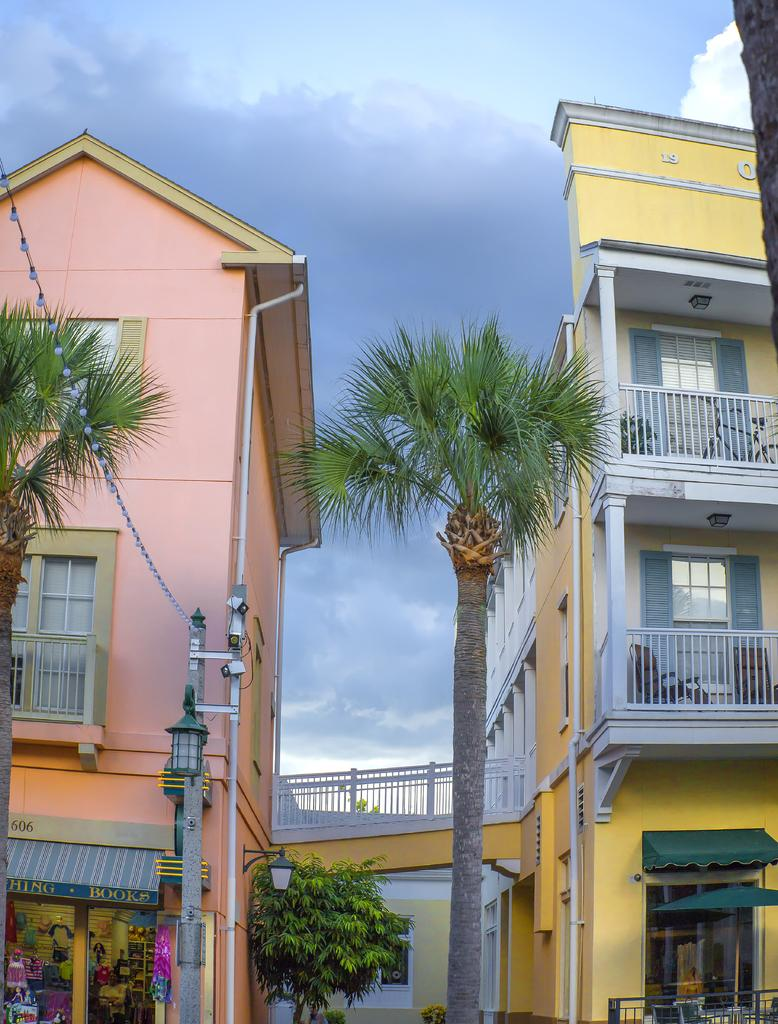What type of structures can be seen in the image? There are buildings in the image. What other natural elements are present in the image? There are trees in the image. What part of the natural environment is visible in the image? The sky is visible in the image. What type of tank is visible in the image? There is no tank present in the image. What is the value of the print in the image? There is no print present in the image, so it is not possible to determine its value. 